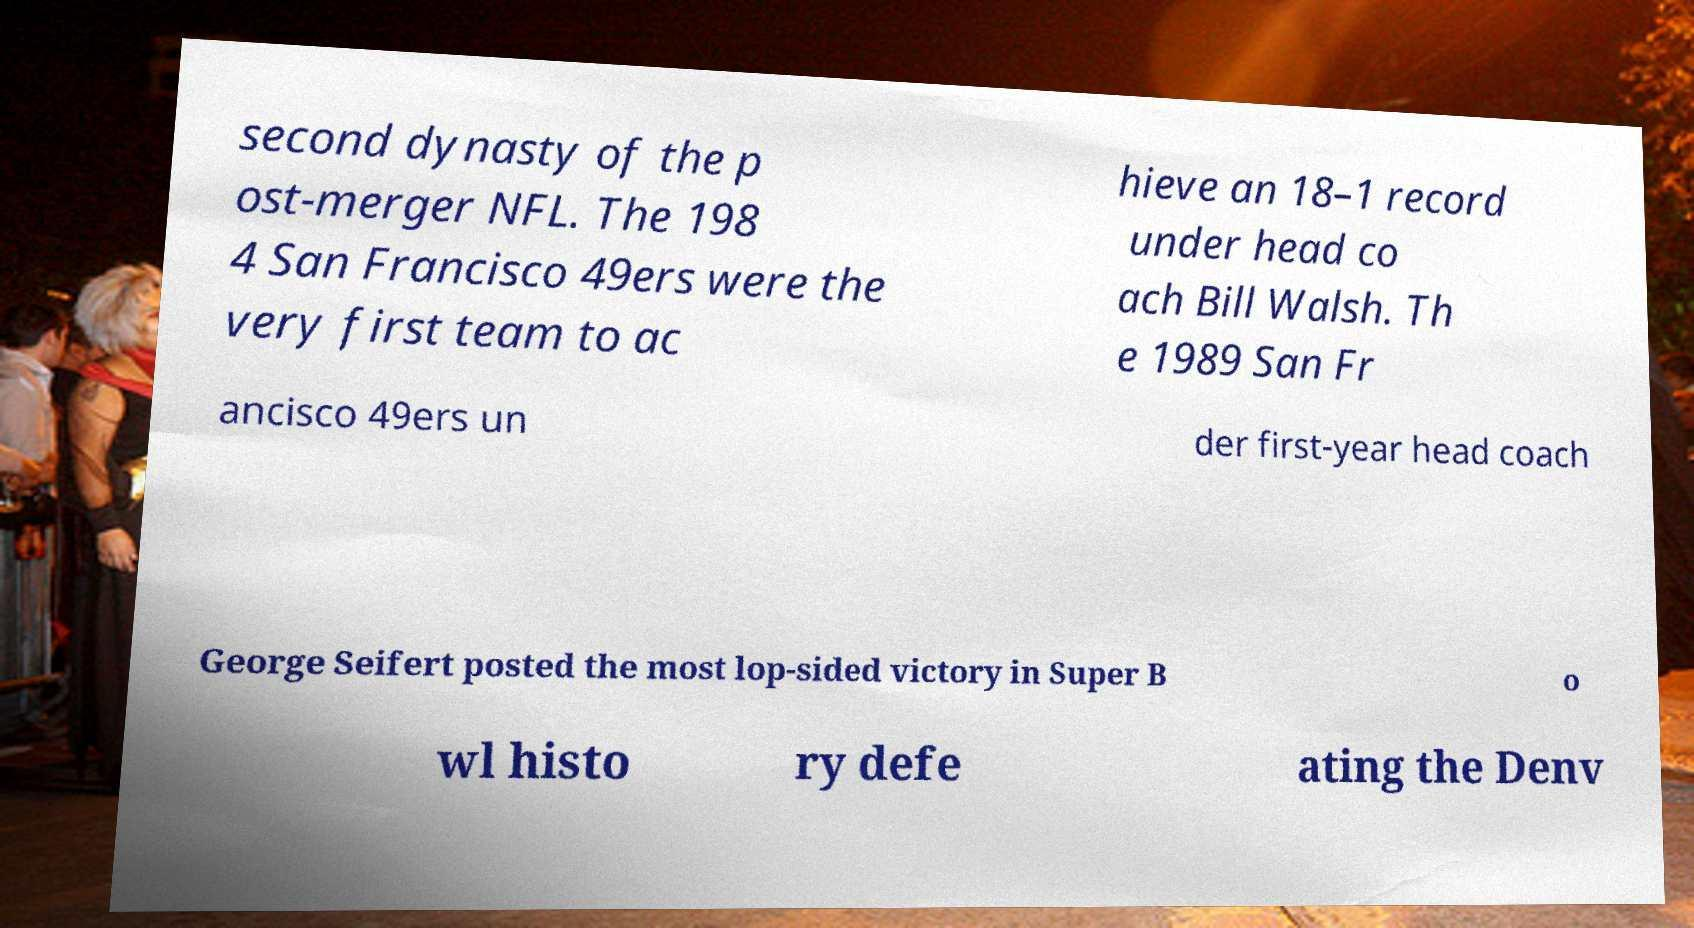Could you assist in decoding the text presented in this image and type it out clearly? second dynasty of the p ost-merger NFL. The 198 4 San Francisco 49ers were the very first team to ac hieve an 18–1 record under head co ach Bill Walsh. Th e 1989 San Fr ancisco 49ers un der first-year head coach George Seifert posted the most lop-sided victory in Super B o wl histo ry defe ating the Denv 